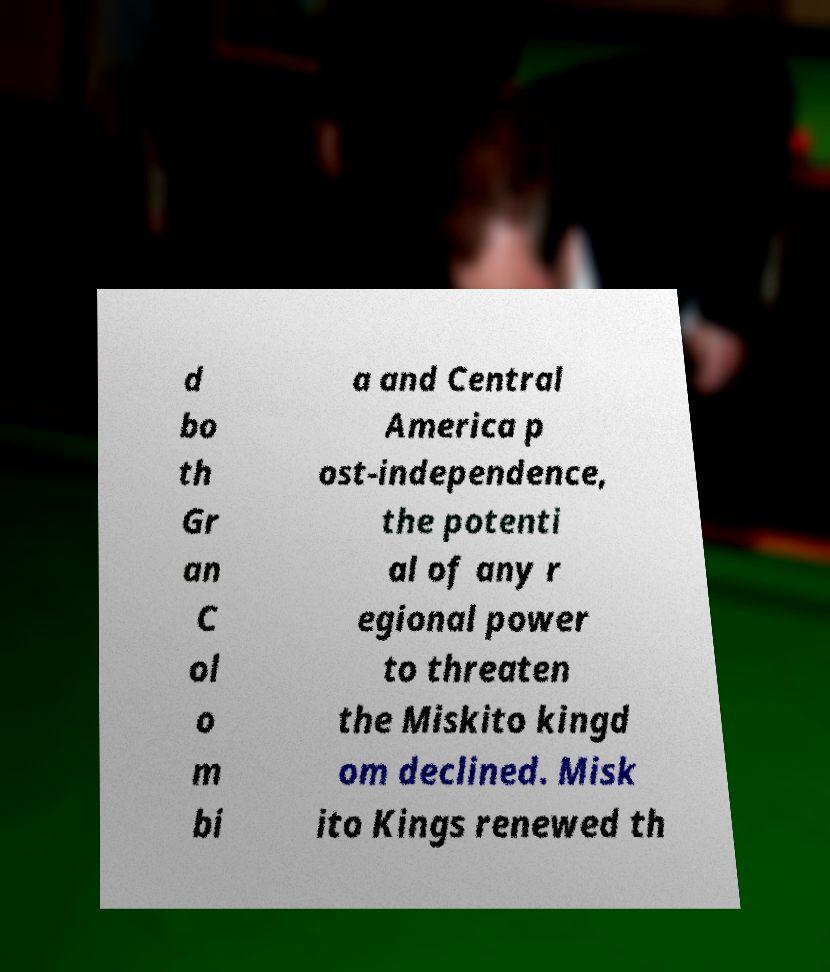Could you extract and type out the text from this image? d bo th Gr an C ol o m bi a and Central America p ost-independence, the potenti al of any r egional power to threaten the Miskito kingd om declined. Misk ito Kings renewed th 